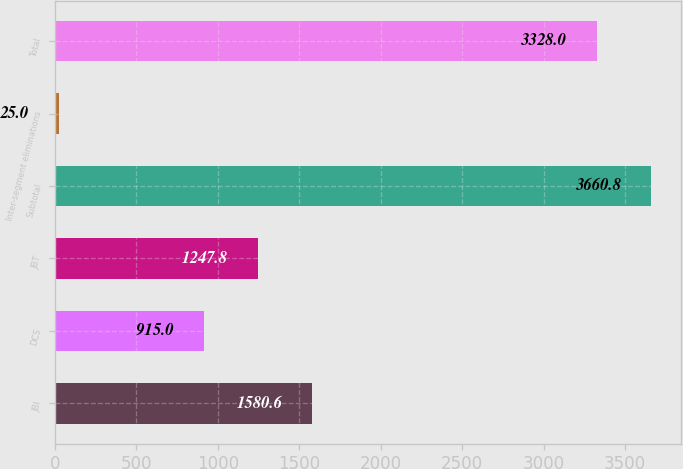Convert chart to OTSL. <chart><loc_0><loc_0><loc_500><loc_500><bar_chart><fcel>JBI<fcel>DCS<fcel>JBT<fcel>Subtotal<fcel>Inter-segment eliminations<fcel>Total<nl><fcel>1580.6<fcel>915<fcel>1247.8<fcel>3660.8<fcel>25<fcel>3328<nl></chart> 